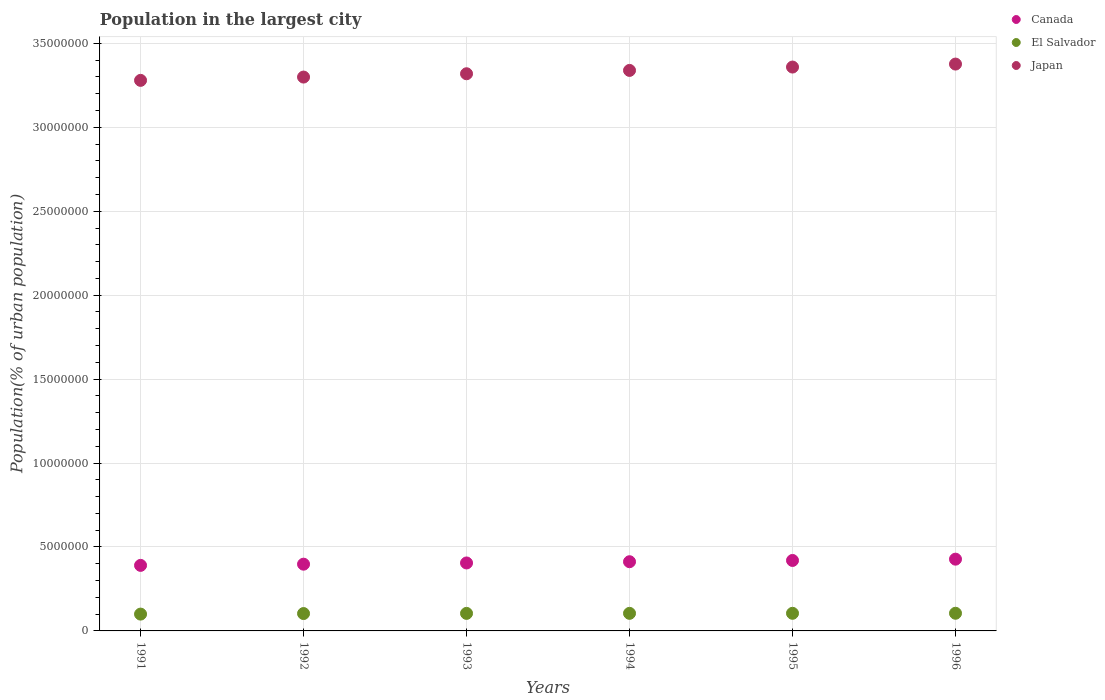Is the number of dotlines equal to the number of legend labels?
Ensure brevity in your answer.  Yes. What is the population in the largest city in Japan in 1996?
Make the answer very short. 3.38e+07. Across all years, what is the maximum population in the largest city in Japan?
Give a very brief answer. 3.38e+07. Across all years, what is the minimum population in the largest city in Japan?
Offer a terse response. 3.28e+07. In which year was the population in the largest city in Canada minimum?
Your response must be concise. 1991. What is the total population in the largest city in El Salvador in the graph?
Offer a very short reply. 6.23e+06. What is the difference between the population in the largest city in Canada in 1992 and that in 1995?
Your answer should be compact. -2.22e+05. What is the difference between the population in the largest city in Japan in 1993 and the population in the largest city in El Salvador in 1994?
Your response must be concise. 3.21e+07. What is the average population in the largest city in Japan per year?
Make the answer very short. 3.33e+07. In the year 1996, what is the difference between the population in the largest city in Japan and population in the largest city in El Salvador?
Offer a very short reply. 3.27e+07. In how many years, is the population in the largest city in Japan greater than 4000000 %?
Ensure brevity in your answer.  6. What is the ratio of the population in the largest city in Japan in 1992 to that in 1994?
Your answer should be compact. 0.99. What is the difference between the highest and the second highest population in the largest city in Japan?
Provide a short and direct response. 1.78e+05. What is the difference between the highest and the lowest population in the largest city in El Salvador?
Provide a short and direct response. 5.03e+04. Is the sum of the population in the largest city in Japan in 1991 and 1992 greater than the maximum population in the largest city in El Salvador across all years?
Your response must be concise. Yes. Is it the case that in every year, the sum of the population in the largest city in El Salvador and population in the largest city in Canada  is greater than the population in the largest city in Japan?
Offer a very short reply. No. Does the population in the largest city in Japan monotonically increase over the years?
Provide a succinct answer. Yes. Is the population in the largest city in Japan strictly less than the population in the largest city in Canada over the years?
Offer a very short reply. No. How many dotlines are there?
Your response must be concise. 3. How many years are there in the graph?
Make the answer very short. 6. Are the values on the major ticks of Y-axis written in scientific E-notation?
Give a very brief answer. No. Does the graph contain any zero values?
Offer a very short reply. No. Where does the legend appear in the graph?
Offer a terse response. Top right. How many legend labels are there?
Offer a very short reply. 3. What is the title of the graph?
Your answer should be compact. Population in the largest city. Does "Curacao" appear as one of the legend labels in the graph?
Offer a very short reply. No. What is the label or title of the X-axis?
Offer a very short reply. Years. What is the label or title of the Y-axis?
Keep it short and to the point. Population(% of urban population). What is the Population(% of urban population) of Canada in 1991?
Ensure brevity in your answer.  3.90e+06. What is the Population(% of urban population) of El Salvador in 1991?
Your response must be concise. 1.00e+06. What is the Population(% of urban population) of Japan in 1991?
Ensure brevity in your answer.  3.28e+07. What is the Population(% of urban population) in Canada in 1992?
Keep it short and to the point. 3.98e+06. What is the Population(% of urban population) of El Salvador in 1992?
Your answer should be very brief. 1.03e+06. What is the Population(% of urban population) of Japan in 1992?
Your answer should be compact. 3.30e+07. What is the Population(% of urban population) in Canada in 1993?
Your answer should be compact. 4.05e+06. What is the Population(% of urban population) of El Salvador in 1993?
Your answer should be very brief. 1.04e+06. What is the Population(% of urban population) of Japan in 1993?
Offer a very short reply. 3.32e+07. What is the Population(% of urban population) of Canada in 1994?
Your response must be concise. 4.12e+06. What is the Population(% of urban population) of El Salvador in 1994?
Provide a succinct answer. 1.05e+06. What is the Population(% of urban population) in Japan in 1994?
Keep it short and to the point. 3.34e+07. What is the Population(% of urban population) in Canada in 1995?
Make the answer very short. 4.20e+06. What is the Population(% of urban population) of El Salvador in 1995?
Your answer should be very brief. 1.05e+06. What is the Population(% of urban population) in Japan in 1995?
Make the answer very short. 3.36e+07. What is the Population(% of urban population) in Canada in 1996?
Provide a succinct answer. 4.27e+06. What is the Population(% of urban population) in El Salvador in 1996?
Offer a very short reply. 1.05e+06. What is the Population(% of urban population) of Japan in 1996?
Your answer should be very brief. 3.38e+07. Across all years, what is the maximum Population(% of urban population) of Canada?
Your answer should be compact. 4.27e+06. Across all years, what is the maximum Population(% of urban population) in El Salvador?
Your response must be concise. 1.05e+06. Across all years, what is the maximum Population(% of urban population) of Japan?
Make the answer very short. 3.38e+07. Across all years, what is the minimum Population(% of urban population) in Canada?
Offer a very short reply. 3.90e+06. Across all years, what is the minimum Population(% of urban population) in El Salvador?
Ensure brevity in your answer.  1.00e+06. Across all years, what is the minimum Population(% of urban population) of Japan?
Provide a short and direct response. 3.28e+07. What is the total Population(% of urban population) in Canada in the graph?
Provide a short and direct response. 2.45e+07. What is the total Population(% of urban population) in El Salvador in the graph?
Give a very brief answer. 6.23e+06. What is the total Population(% of urban population) of Japan in the graph?
Your answer should be compact. 2.00e+08. What is the difference between the Population(% of urban population) of Canada in 1991 and that in 1992?
Offer a terse response. -7.14e+04. What is the difference between the Population(% of urban population) in El Salvador in 1991 and that in 1992?
Make the answer very short. -3.31e+04. What is the difference between the Population(% of urban population) of Japan in 1991 and that in 1992?
Your response must be concise. -1.97e+05. What is the difference between the Population(% of urban population) of Canada in 1991 and that in 1993?
Make the answer very short. -1.44e+05. What is the difference between the Population(% of urban population) of El Salvador in 1991 and that in 1993?
Offer a very short reply. -4.30e+04. What is the difference between the Population(% of urban population) of Japan in 1991 and that in 1993?
Keep it short and to the point. -3.94e+05. What is the difference between the Population(% of urban population) in Canada in 1991 and that in 1994?
Offer a terse response. -2.18e+05. What is the difference between the Population(% of urban population) of El Salvador in 1991 and that in 1994?
Your answer should be compact. -4.54e+04. What is the difference between the Population(% of urban population) of Japan in 1991 and that in 1994?
Your response must be concise. -5.93e+05. What is the difference between the Population(% of urban population) in Canada in 1991 and that in 1995?
Offer a very short reply. -2.93e+05. What is the difference between the Population(% of urban population) of El Salvador in 1991 and that in 1995?
Offer a very short reply. -4.78e+04. What is the difference between the Population(% of urban population) of Japan in 1991 and that in 1995?
Your answer should be compact. -7.93e+05. What is the difference between the Population(% of urban population) in Canada in 1991 and that in 1996?
Offer a terse response. -3.70e+05. What is the difference between the Population(% of urban population) of El Salvador in 1991 and that in 1996?
Your answer should be compact. -5.03e+04. What is the difference between the Population(% of urban population) in Japan in 1991 and that in 1996?
Keep it short and to the point. -9.70e+05. What is the difference between the Population(% of urban population) in Canada in 1992 and that in 1993?
Provide a short and direct response. -7.25e+04. What is the difference between the Population(% of urban population) of El Salvador in 1992 and that in 1993?
Keep it short and to the point. -9927. What is the difference between the Population(% of urban population) in Japan in 1992 and that in 1993?
Make the answer very short. -1.97e+05. What is the difference between the Population(% of urban population) in Canada in 1992 and that in 1994?
Your response must be concise. -1.46e+05. What is the difference between the Population(% of urban population) of El Salvador in 1992 and that in 1994?
Ensure brevity in your answer.  -1.23e+04. What is the difference between the Population(% of urban population) in Japan in 1992 and that in 1994?
Offer a very short reply. -3.96e+05. What is the difference between the Population(% of urban population) in Canada in 1992 and that in 1995?
Your response must be concise. -2.22e+05. What is the difference between the Population(% of urban population) of El Salvador in 1992 and that in 1995?
Make the answer very short. -1.48e+04. What is the difference between the Population(% of urban population) of Japan in 1992 and that in 1995?
Ensure brevity in your answer.  -5.96e+05. What is the difference between the Population(% of urban population) in Canada in 1992 and that in 1996?
Make the answer very short. -2.99e+05. What is the difference between the Population(% of urban population) of El Salvador in 1992 and that in 1996?
Your response must be concise. -1.72e+04. What is the difference between the Population(% of urban population) of Japan in 1992 and that in 1996?
Give a very brief answer. -7.74e+05. What is the difference between the Population(% of urban population) of Canada in 1993 and that in 1994?
Provide a succinct answer. -7.39e+04. What is the difference between the Population(% of urban population) of El Salvador in 1993 and that in 1994?
Offer a terse response. -2417. What is the difference between the Population(% of urban population) of Japan in 1993 and that in 1994?
Provide a short and direct response. -1.99e+05. What is the difference between the Population(% of urban population) in Canada in 1993 and that in 1995?
Your answer should be compact. -1.49e+05. What is the difference between the Population(% of urban population) of El Salvador in 1993 and that in 1995?
Your response must be concise. -4839. What is the difference between the Population(% of urban population) in Japan in 1993 and that in 1995?
Your answer should be very brief. -3.99e+05. What is the difference between the Population(% of urban population) in Canada in 1993 and that in 1996?
Your answer should be very brief. -2.26e+05. What is the difference between the Population(% of urban population) of El Salvador in 1993 and that in 1996?
Ensure brevity in your answer.  -7271. What is the difference between the Population(% of urban population) in Japan in 1993 and that in 1996?
Make the answer very short. -5.76e+05. What is the difference between the Population(% of urban population) of Canada in 1994 and that in 1995?
Provide a short and direct response. -7.52e+04. What is the difference between the Population(% of urban population) in El Salvador in 1994 and that in 1995?
Give a very brief answer. -2422. What is the difference between the Population(% of urban population) of Japan in 1994 and that in 1995?
Provide a short and direct response. -2.00e+05. What is the difference between the Population(% of urban population) of Canada in 1994 and that in 1996?
Give a very brief answer. -1.52e+05. What is the difference between the Population(% of urban population) in El Salvador in 1994 and that in 1996?
Offer a very short reply. -4854. What is the difference between the Population(% of urban population) of Japan in 1994 and that in 1996?
Your answer should be very brief. -3.78e+05. What is the difference between the Population(% of urban population) in Canada in 1995 and that in 1996?
Provide a short and direct response. -7.71e+04. What is the difference between the Population(% of urban population) of El Salvador in 1995 and that in 1996?
Your answer should be compact. -2432. What is the difference between the Population(% of urban population) in Japan in 1995 and that in 1996?
Your answer should be compact. -1.78e+05. What is the difference between the Population(% of urban population) in Canada in 1991 and the Population(% of urban population) in El Salvador in 1992?
Make the answer very short. 2.87e+06. What is the difference between the Population(% of urban population) of Canada in 1991 and the Population(% of urban population) of Japan in 1992?
Give a very brief answer. -2.91e+07. What is the difference between the Population(% of urban population) of El Salvador in 1991 and the Population(% of urban population) of Japan in 1992?
Offer a terse response. -3.20e+07. What is the difference between the Population(% of urban population) in Canada in 1991 and the Population(% of urban population) in El Salvador in 1993?
Make the answer very short. 2.86e+06. What is the difference between the Population(% of urban population) in Canada in 1991 and the Population(% of urban population) in Japan in 1993?
Make the answer very short. -2.93e+07. What is the difference between the Population(% of urban population) in El Salvador in 1991 and the Population(% of urban population) in Japan in 1993?
Your response must be concise. -3.22e+07. What is the difference between the Population(% of urban population) of Canada in 1991 and the Population(% of urban population) of El Salvador in 1994?
Offer a very short reply. 2.86e+06. What is the difference between the Population(% of urban population) in Canada in 1991 and the Population(% of urban population) in Japan in 1994?
Keep it short and to the point. -2.95e+07. What is the difference between the Population(% of urban population) of El Salvador in 1991 and the Population(% of urban population) of Japan in 1994?
Your response must be concise. -3.24e+07. What is the difference between the Population(% of urban population) of Canada in 1991 and the Population(% of urban population) of El Salvador in 1995?
Provide a succinct answer. 2.85e+06. What is the difference between the Population(% of urban population) in Canada in 1991 and the Population(% of urban population) in Japan in 1995?
Offer a terse response. -2.97e+07. What is the difference between the Population(% of urban population) of El Salvador in 1991 and the Population(% of urban population) of Japan in 1995?
Your answer should be very brief. -3.26e+07. What is the difference between the Population(% of urban population) in Canada in 1991 and the Population(% of urban population) in El Salvador in 1996?
Make the answer very short. 2.85e+06. What is the difference between the Population(% of urban population) of Canada in 1991 and the Population(% of urban population) of Japan in 1996?
Provide a short and direct response. -2.99e+07. What is the difference between the Population(% of urban population) of El Salvador in 1991 and the Population(% of urban population) of Japan in 1996?
Offer a terse response. -3.28e+07. What is the difference between the Population(% of urban population) of Canada in 1992 and the Population(% of urban population) of El Salvador in 1993?
Ensure brevity in your answer.  2.93e+06. What is the difference between the Population(% of urban population) in Canada in 1992 and the Population(% of urban population) in Japan in 1993?
Offer a very short reply. -2.92e+07. What is the difference between the Population(% of urban population) in El Salvador in 1992 and the Population(% of urban population) in Japan in 1993?
Provide a short and direct response. -3.22e+07. What is the difference between the Population(% of urban population) of Canada in 1992 and the Population(% of urban population) of El Salvador in 1994?
Offer a very short reply. 2.93e+06. What is the difference between the Population(% of urban population) in Canada in 1992 and the Population(% of urban population) in Japan in 1994?
Your answer should be very brief. -2.94e+07. What is the difference between the Population(% of urban population) in El Salvador in 1992 and the Population(% of urban population) in Japan in 1994?
Offer a terse response. -3.24e+07. What is the difference between the Population(% of urban population) of Canada in 1992 and the Population(% of urban population) of El Salvador in 1995?
Offer a terse response. 2.93e+06. What is the difference between the Population(% of urban population) of Canada in 1992 and the Population(% of urban population) of Japan in 1995?
Ensure brevity in your answer.  -2.96e+07. What is the difference between the Population(% of urban population) of El Salvador in 1992 and the Population(% of urban population) of Japan in 1995?
Make the answer very short. -3.26e+07. What is the difference between the Population(% of urban population) in Canada in 1992 and the Population(% of urban population) in El Salvador in 1996?
Provide a short and direct response. 2.92e+06. What is the difference between the Population(% of urban population) of Canada in 1992 and the Population(% of urban population) of Japan in 1996?
Provide a short and direct response. -2.98e+07. What is the difference between the Population(% of urban population) of El Salvador in 1992 and the Population(% of urban population) of Japan in 1996?
Provide a succinct answer. -3.27e+07. What is the difference between the Population(% of urban population) of Canada in 1993 and the Population(% of urban population) of El Salvador in 1994?
Offer a very short reply. 3.00e+06. What is the difference between the Population(% of urban population) in Canada in 1993 and the Population(% of urban population) in Japan in 1994?
Provide a succinct answer. -2.93e+07. What is the difference between the Population(% of urban population) of El Salvador in 1993 and the Population(% of urban population) of Japan in 1994?
Provide a succinct answer. -3.23e+07. What is the difference between the Population(% of urban population) in Canada in 1993 and the Population(% of urban population) in El Salvador in 1995?
Ensure brevity in your answer.  3.00e+06. What is the difference between the Population(% of urban population) of Canada in 1993 and the Population(% of urban population) of Japan in 1995?
Provide a succinct answer. -2.95e+07. What is the difference between the Population(% of urban population) in El Salvador in 1993 and the Population(% of urban population) in Japan in 1995?
Make the answer very short. -3.25e+07. What is the difference between the Population(% of urban population) in Canada in 1993 and the Population(% of urban population) in El Salvador in 1996?
Offer a very short reply. 3.00e+06. What is the difference between the Population(% of urban population) in Canada in 1993 and the Population(% of urban population) in Japan in 1996?
Provide a succinct answer. -2.97e+07. What is the difference between the Population(% of urban population) of El Salvador in 1993 and the Population(% of urban population) of Japan in 1996?
Provide a succinct answer. -3.27e+07. What is the difference between the Population(% of urban population) of Canada in 1994 and the Population(% of urban population) of El Salvador in 1995?
Your response must be concise. 3.07e+06. What is the difference between the Population(% of urban population) in Canada in 1994 and the Population(% of urban population) in Japan in 1995?
Provide a succinct answer. -2.95e+07. What is the difference between the Population(% of urban population) in El Salvador in 1994 and the Population(% of urban population) in Japan in 1995?
Your answer should be very brief. -3.25e+07. What is the difference between the Population(% of urban population) of Canada in 1994 and the Population(% of urban population) of El Salvador in 1996?
Keep it short and to the point. 3.07e+06. What is the difference between the Population(% of urban population) of Canada in 1994 and the Population(% of urban population) of Japan in 1996?
Provide a short and direct response. -2.96e+07. What is the difference between the Population(% of urban population) of El Salvador in 1994 and the Population(% of urban population) of Japan in 1996?
Provide a succinct answer. -3.27e+07. What is the difference between the Population(% of urban population) in Canada in 1995 and the Population(% of urban population) in El Salvador in 1996?
Your answer should be compact. 3.15e+06. What is the difference between the Population(% of urban population) in Canada in 1995 and the Population(% of urban population) in Japan in 1996?
Provide a short and direct response. -2.96e+07. What is the difference between the Population(% of urban population) of El Salvador in 1995 and the Population(% of urban population) of Japan in 1996?
Offer a terse response. -3.27e+07. What is the average Population(% of urban population) in Canada per year?
Provide a short and direct response. 4.09e+06. What is the average Population(% of urban population) in El Salvador per year?
Your response must be concise. 1.04e+06. What is the average Population(% of urban population) in Japan per year?
Provide a succinct answer. 3.33e+07. In the year 1991, what is the difference between the Population(% of urban population) in Canada and Population(% of urban population) in El Salvador?
Give a very brief answer. 2.90e+06. In the year 1991, what is the difference between the Population(% of urban population) of Canada and Population(% of urban population) of Japan?
Your response must be concise. -2.89e+07. In the year 1991, what is the difference between the Population(% of urban population) in El Salvador and Population(% of urban population) in Japan?
Your answer should be very brief. -3.18e+07. In the year 1992, what is the difference between the Population(% of urban population) in Canada and Population(% of urban population) in El Salvador?
Ensure brevity in your answer.  2.94e+06. In the year 1992, what is the difference between the Population(% of urban population) of Canada and Population(% of urban population) of Japan?
Keep it short and to the point. -2.90e+07. In the year 1992, what is the difference between the Population(% of urban population) of El Salvador and Population(% of urban population) of Japan?
Your answer should be compact. -3.20e+07. In the year 1993, what is the difference between the Population(% of urban population) in Canada and Population(% of urban population) in El Salvador?
Offer a terse response. 3.00e+06. In the year 1993, what is the difference between the Population(% of urban population) in Canada and Population(% of urban population) in Japan?
Provide a short and direct response. -2.91e+07. In the year 1993, what is the difference between the Population(% of urban population) in El Salvador and Population(% of urban population) in Japan?
Make the answer very short. -3.21e+07. In the year 1994, what is the difference between the Population(% of urban population) in Canada and Population(% of urban population) in El Salvador?
Make the answer very short. 3.07e+06. In the year 1994, what is the difference between the Population(% of urban population) in Canada and Population(% of urban population) in Japan?
Keep it short and to the point. -2.93e+07. In the year 1994, what is the difference between the Population(% of urban population) of El Salvador and Population(% of urban population) of Japan?
Your response must be concise. -3.23e+07. In the year 1995, what is the difference between the Population(% of urban population) of Canada and Population(% of urban population) of El Salvador?
Give a very brief answer. 3.15e+06. In the year 1995, what is the difference between the Population(% of urban population) of Canada and Population(% of urban population) of Japan?
Make the answer very short. -2.94e+07. In the year 1995, what is the difference between the Population(% of urban population) of El Salvador and Population(% of urban population) of Japan?
Offer a terse response. -3.25e+07. In the year 1996, what is the difference between the Population(% of urban population) in Canada and Population(% of urban population) in El Salvador?
Provide a succinct answer. 3.22e+06. In the year 1996, what is the difference between the Population(% of urban population) in Canada and Population(% of urban population) in Japan?
Your response must be concise. -2.95e+07. In the year 1996, what is the difference between the Population(% of urban population) of El Salvador and Population(% of urban population) of Japan?
Your answer should be compact. -3.27e+07. What is the ratio of the Population(% of urban population) in Canada in 1991 to that in 1992?
Ensure brevity in your answer.  0.98. What is the ratio of the Population(% of urban population) in El Salvador in 1991 to that in 1992?
Give a very brief answer. 0.97. What is the ratio of the Population(% of urban population) of Japan in 1991 to that in 1992?
Your response must be concise. 0.99. What is the ratio of the Population(% of urban population) in Canada in 1991 to that in 1993?
Keep it short and to the point. 0.96. What is the ratio of the Population(% of urban population) of El Salvador in 1991 to that in 1993?
Provide a short and direct response. 0.96. What is the ratio of the Population(% of urban population) of Japan in 1991 to that in 1993?
Offer a terse response. 0.99. What is the ratio of the Population(% of urban population) of Canada in 1991 to that in 1994?
Your response must be concise. 0.95. What is the ratio of the Population(% of urban population) of El Salvador in 1991 to that in 1994?
Offer a very short reply. 0.96. What is the ratio of the Population(% of urban population) in Japan in 1991 to that in 1994?
Offer a terse response. 0.98. What is the ratio of the Population(% of urban population) of Canada in 1991 to that in 1995?
Ensure brevity in your answer.  0.93. What is the ratio of the Population(% of urban population) in El Salvador in 1991 to that in 1995?
Your answer should be compact. 0.95. What is the ratio of the Population(% of urban population) of Japan in 1991 to that in 1995?
Provide a short and direct response. 0.98. What is the ratio of the Population(% of urban population) in Canada in 1991 to that in 1996?
Give a very brief answer. 0.91. What is the ratio of the Population(% of urban population) in El Salvador in 1991 to that in 1996?
Your response must be concise. 0.95. What is the ratio of the Population(% of urban population) of Japan in 1991 to that in 1996?
Provide a succinct answer. 0.97. What is the ratio of the Population(% of urban population) of Canada in 1992 to that in 1993?
Your response must be concise. 0.98. What is the ratio of the Population(% of urban population) of El Salvador in 1992 to that in 1993?
Your answer should be compact. 0.99. What is the ratio of the Population(% of urban population) of Japan in 1992 to that in 1993?
Provide a succinct answer. 0.99. What is the ratio of the Population(% of urban population) in Canada in 1992 to that in 1994?
Ensure brevity in your answer.  0.96. What is the ratio of the Population(% of urban population) in Japan in 1992 to that in 1994?
Offer a very short reply. 0.99. What is the ratio of the Population(% of urban population) in Canada in 1992 to that in 1995?
Your answer should be very brief. 0.95. What is the ratio of the Population(% of urban population) of El Salvador in 1992 to that in 1995?
Keep it short and to the point. 0.99. What is the ratio of the Population(% of urban population) of Japan in 1992 to that in 1995?
Offer a very short reply. 0.98. What is the ratio of the Population(% of urban population) of Canada in 1992 to that in 1996?
Your answer should be compact. 0.93. What is the ratio of the Population(% of urban population) in El Salvador in 1992 to that in 1996?
Your answer should be very brief. 0.98. What is the ratio of the Population(% of urban population) in Japan in 1992 to that in 1996?
Offer a terse response. 0.98. What is the ratio of the Population(% of urban population) of Canada in 1993 to that in 1994?
Give a very brief answer. 0.98. What is the ratio of the Population(% of urban population) of Japan in 1993 to that in 1994?
Offer a terse response. 0.99. What is the ratio of the Population(% of urban population) of Canada in 1993 to that in 1995?
Ensure brevity in your answer.  0.96. What is the ratio of the Population(% of urban population) in El Salvador in 1993 to that in 1995?
Provide a short and direct response. 1. What is the ratio of the Population(% of urban population) of Canada in 1993 to that in 1996?
Your response must be concise. 0.95. What is the ratio of the Population(% of urban population) in El Salvador in 1993 to that in 1996?
Offer a terse response. 0.99. What is the ratio of the Population(% of urban population) in Japan in 1993 to that in 1996?
Make the answer very short. 0.98. What is the ratio of the Population(% of urban population) of Canada in 1994 to that in 1995?
Provide a short and direct response. 0.98. What is the ratio of the Population(% of urban population) of Canada in 1994 to that in 1996?
Provide a succinct answer. 0.96. What is the ratio of the Population(% of urban population) in Japan in 1994 to that in 1996?
Provide a succinct answer. 0.99. What is the ratio of the Population(% of urban population) in El Salvador in 1995 to that in 1996?
Offer a very short reply. 1. What is the difference between the highest and the second highest Population(% of urban population) of Canada?
Ensure brevity in your answer.  7.71e+04. What is the difference between the highest and the second highest Population(% of urban population) in El Salvador?
Provide a short and direct response. 2432. What is the difference between the highest and the second highest Population(% of urban population) of Japan?
Keep it short and to the point. 1.78e+05. What is the difference between the highest and the lowest Population(% of urban population) in Canada?
Offer a terse response. 3.70e+05. What is the difference between the highest and the lowest Population(% of urban population) in El Salvador?
Ensure brevity in your answer.  5.03e+04. What is the difference between the highest and the lowest Population(% of urban population) of Japan?
Ensure brevity in your answer.  9.70e+05. 